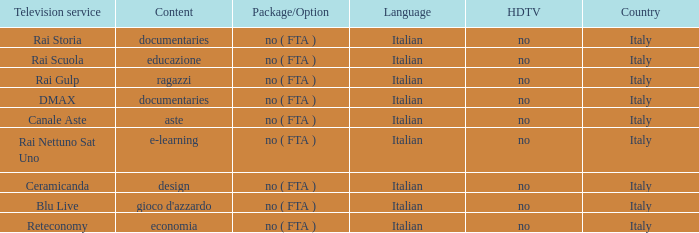What is the Country with Reteconomy as the Television service? Italy. Would you mind parsing the complete table? {'header': ['Television service', 'Content', 'Package/Option', 'Language', 'HDTV', 'Country'], 'rows': [['Rai Storia', 'documentaries', 'no ( FTA )', 'Italian', 'no', 'Italy'], ['Rai Scuola', 'educazione', 'no ( FTA )', 'Italian', 'no', 'Italy'], ['Rai Gulp', 'ragazzi', 'no ( FTA )', 'Italian', 'no', 'Italy'], ['DMAX', 'documentaries', 'no ( FTA )', 'Italian', 'no', 'Italy'], ['Canale Aste', 'aste', 'no ( FTA )', 'Italian', 'no', 'Italy'], ['Rai Nettuno Sat Uno', 'e-learning', 'no ( FTA )', 'Italian', 'no', 'Italy'], ['Ceramicanda', 'design', 'no ( FTA )', 'Italian', 'no', 'Italy'], ['Blu Live', "gioco d'azzardo", 'no ( FTA )', 'Italian', 'no', 'Italy'], ['Reteconomy', 'economia', 'no ( FTA )', 'Italian', 'no', 'Italy']]} 